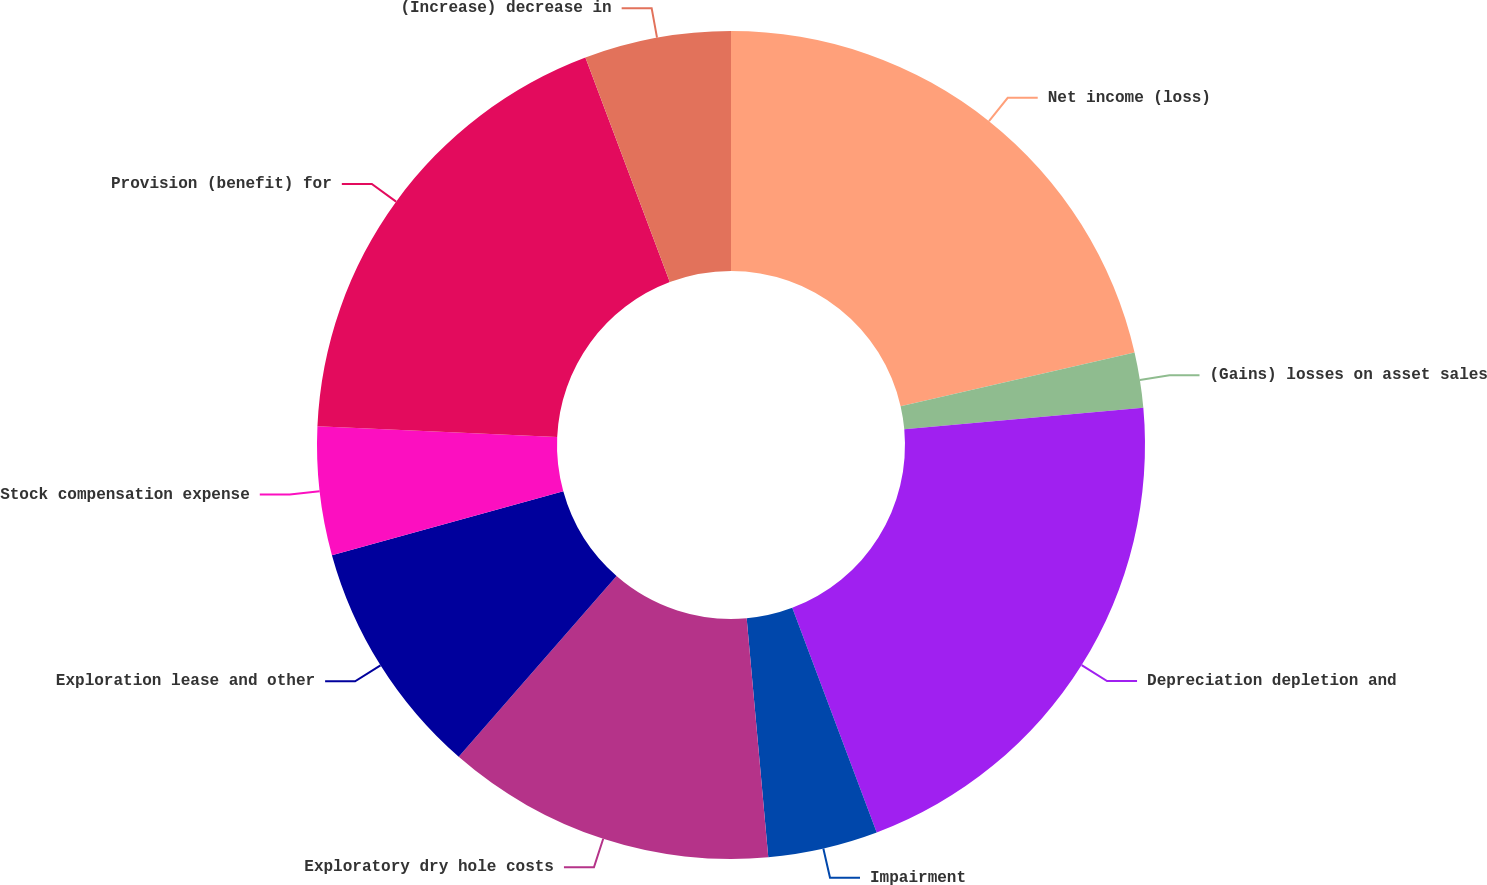Convert chart. <chart><loc_0><loc_0><loc_500><loc_500><pie_chart><fcel>Net income (loss)<fcel>(Gains) losses on asset sales<fcel>Depreciation depletion and<fcel>Impairment<fcel>Exploratory dry hole costs<fcel>Exploration lease and other<fcel>Stock compensation expense<fcel>Provision (benefit) for<fcel>(Increase) decrease in<nl><fcel>21.42%<fcel>2.15%<fcel>20.71%<fcel>4.29%<fcel>12.86%<fcel>9.29%<fcel>5.01%<fcel>18.56%<fcel>5.72%<nl></chart> 